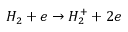Convert formula to latex. <formula><loc_0><loc_0><loc_500><loc_500>H _ { 2 } + e \rightarrow H _ { 2 } ^ { + } + 2 e</formula> 